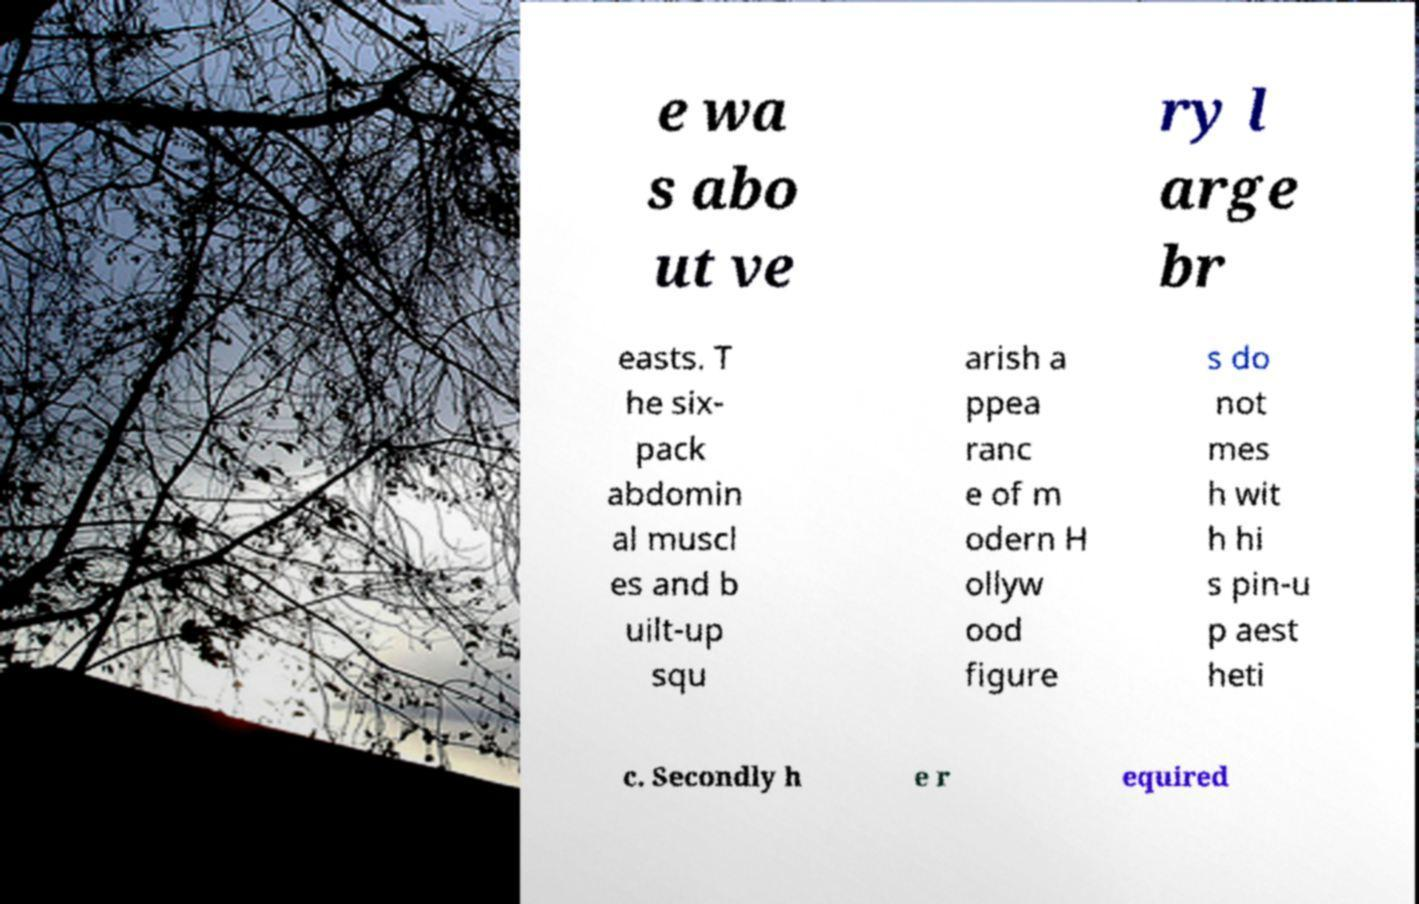Can you accurately transcribe the text from the provided image for me? e wa s abo ut ve ry l arge br easts. T he six- pack abdomin al muscl es and b uilt-up squ arish a ppea ranc e of m odern H ollyw ood figure s do not mes h wit h hi s pin-u p aest heti c. Secondly h e r equired 